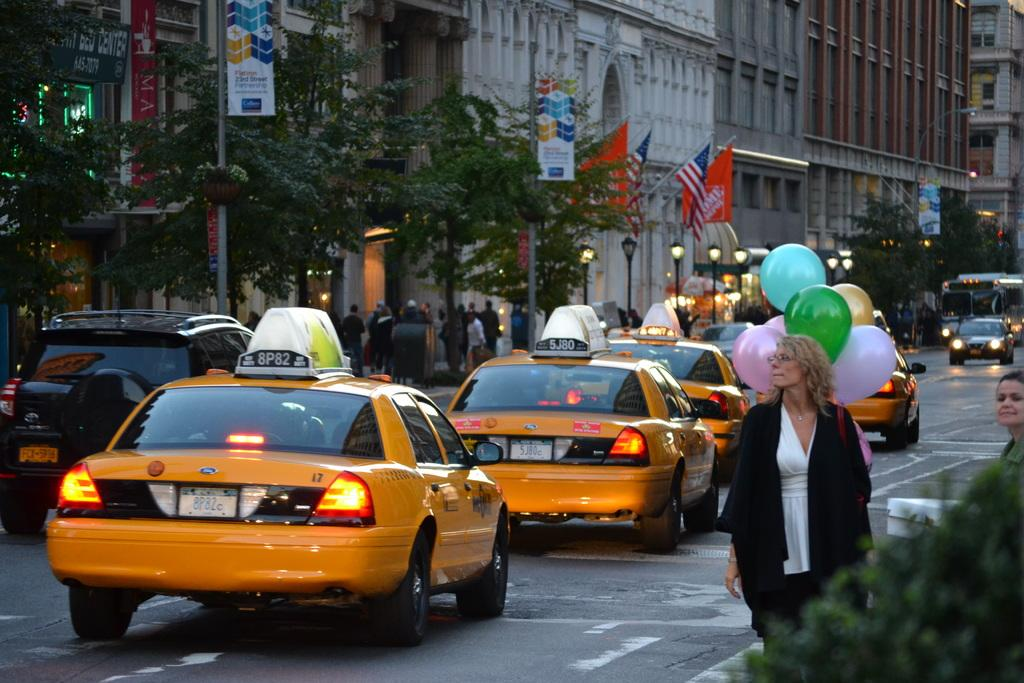<image>
Relay a brief, clear account of the picture shown. Taxi 8P82 is last in line of taxis on a city street. 